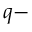Convert formula to latex. <formula><loc_0><loc_0><loc_500><loc_500>q -</formula> 